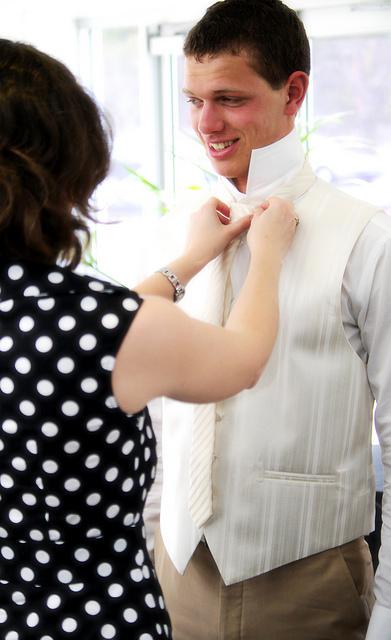Can't the guy dress himself?
Write a very short answer. Yes. Is the man happy?
Short answer required. Yes. What is the woman doing?
Answer briefly. Tying tie. 